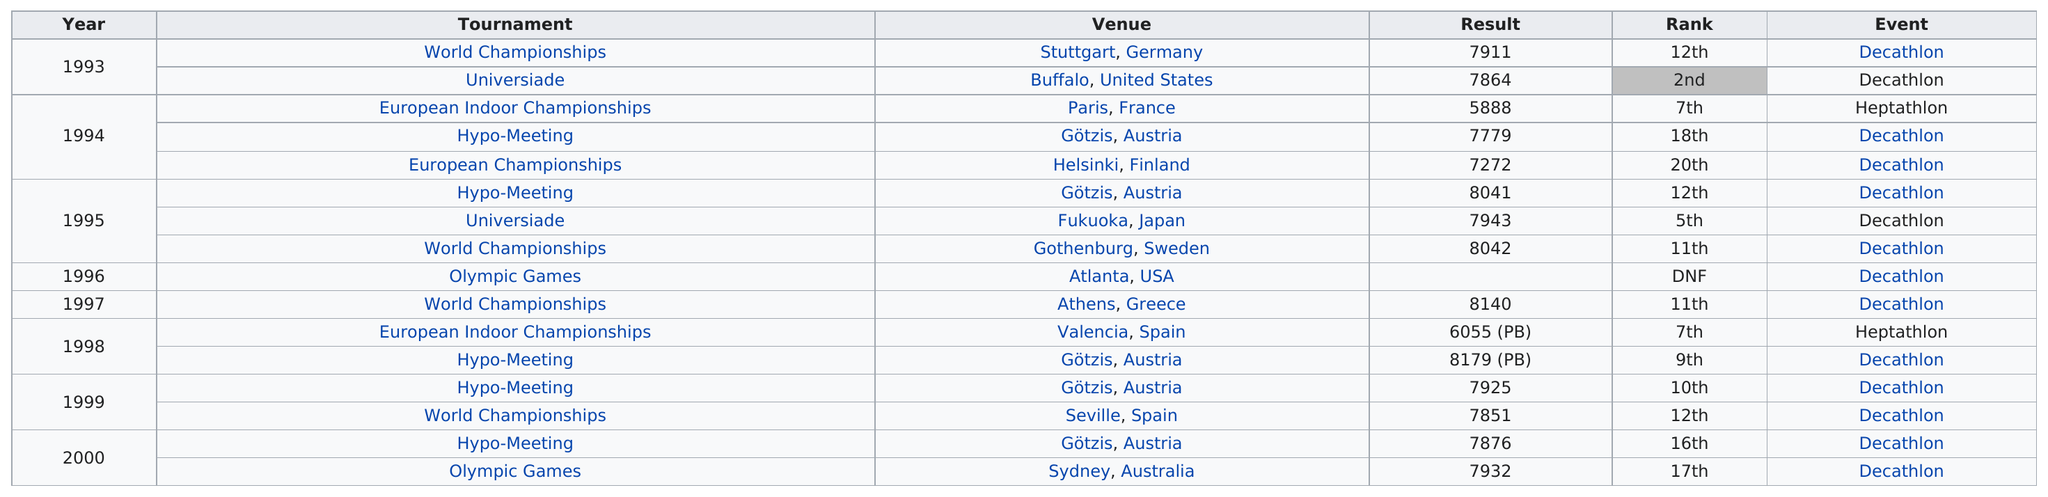Highlight a few significant elements in this photo. Kaseorg attempted but did not complete the decathlon in Atlanta, USA. The years are in consecutive order. The World Championships are at the top of all tournaments. The United States held the second rank a total of 1 time. Kaseorg placed 10th or better in 6 out of the total number of meetings. 